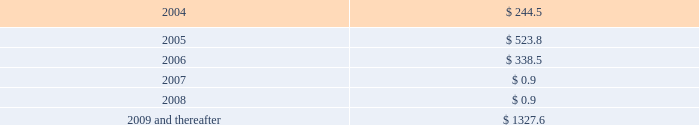Notes to consolidated financial statements ( dollars in millions , except per share amounts ) long-term debt maturing over the next five years and thereafter is as follows: .
On march 7 , 2003 , standard & poor's ratings services downgraded the company's senior secured credit rating to bb+ with negative outlook from bbb- .
On may 14 , 2003 , fitch ratings downgraded the company's senior unsecured credit rating to bb+ with negative outlook from bbb- .
On may 9 , 2003 , moody's investor services , inc .
( "moody's" ) placed the company's senior unsecured and subordinated credit ratings on review for possible downgrade from baa3 and ba1 , respectively .
As of march 12 , 2004 , the company's credit ratings continued to be on review for a possible downgrade .
Since july 2001 , the company has not repurchased its common stock in the open market .
In october 2003 , the company received a federal tax refund of approximately $ 90 as a result of its carryback of its 2002 loss for us federal income tax purposes and certain capital losses , to earlier periods .
Through december 2002 , the company had paid cash dividends quarterly with the most recent quarterly dividend paid in december 2002 at a rate of $ 0.095 per share .
On a quarterly basis , the company's board of directors makes determinations regarding the payment of dividends .
As previously discussed , the company's ability to declare or pay dividends is currently restricted by the terms of its revolving credit facilities .
The company did not declare or pay any dividends in 2003 .
However , in 2004 , the company expects to pay any dividends accruing on the series a mandatory convertible preferred stock in cash , which is expressly permitted by the revolving credit facilities .
See note 14 for discussion of fair market value of the company's long-term debt .
Note 9 : equity offering on december 16 , 2003 , the company sold 25.8 million shares of common stock and issued 7.5 million shares of 3- year series a mandatory convertible preferred stock ( the "preferred stock" ) .
The total net proceeds received from the concurrent offerings was approximately $ 693 .
The preferred stock carries a dividend yield of 5.375% ( 5.375 % ) .
On maturity , each share of the preferred stock will convert , subject to adjustment , to between 3.0358 and 3.7037 shares of common stock , depending on the then-current market price of the company's common stock , representing a conversion premium of approximately 22% ( 22 % ) over the stock offering price of $ 13.50 per share .
Under certain circumstances , the preferred stock may be converted prior to maturity at the option of the holders or the company .
The common and preferred stock were issued under the company's existing shelf registration statement .
In january 2004 , the company used approximately $ 246 of the net proceeds from the offerings to redeem the 1.80% ( 1.80 % ) convertible subordinated notes due 2004 .
The remaining proceeds will be used for general corporate purposes and to further strengthen the company's balance sheet and financial condition .
The company will pay annual dividends on each share of the series a mandatory convertible preferred stock in the amount of $ 2.6875 .
Dividends will be cumulative from the date of issuance and will be payable on each payment date to the extent that dividends are not restricted under the company's credit facilities and assets are legally available to pay dividends .
The first dividend payment , which was declared on february 24 , 2004 , will be made on march 15 , 2004. .
How much percentage has long-term debt gone down from 2004 to 2008? 
Rationale: to find the percentage decrease you need to subtract 2004 by 2008 to get 243.6 million . then you take this and divide by 2004 which will give you 99.6%
Computations: ((244.5 - 0.9) / 244.5)
Answer: 0.99632. 